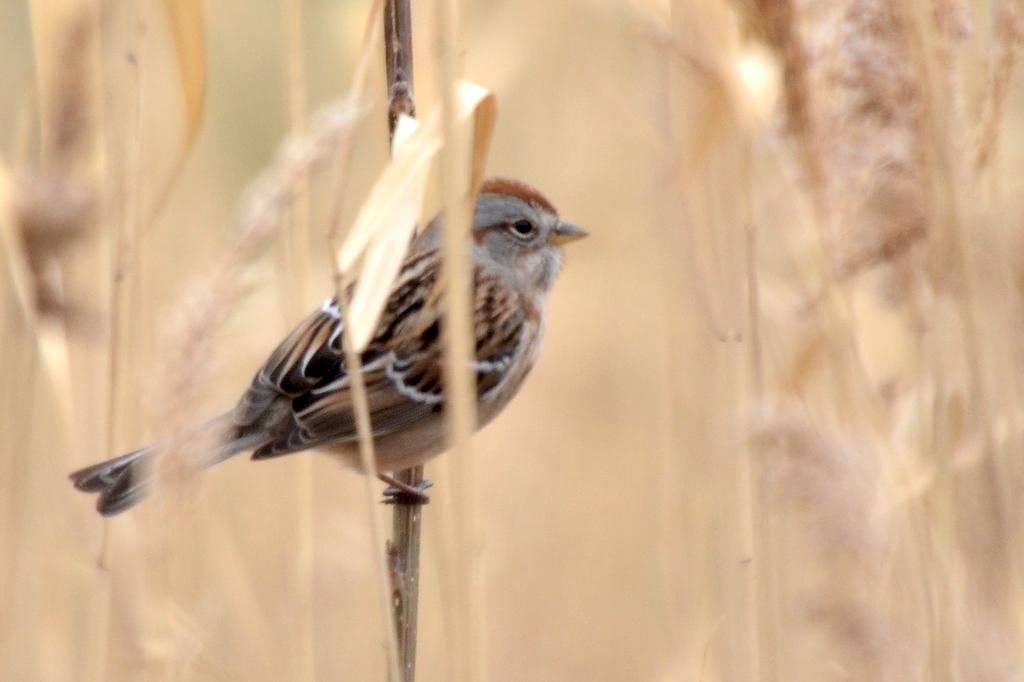What type of animal can be seen in the image? There is a bird in the image. Where is the bird located in the image? The bird is on a stem in the image. What other living organisms are present in the image? There are plants in the image. What language is the bird speaking in the image? Birds do not speak human languages, so there is no language spoken by the bird in the image. 